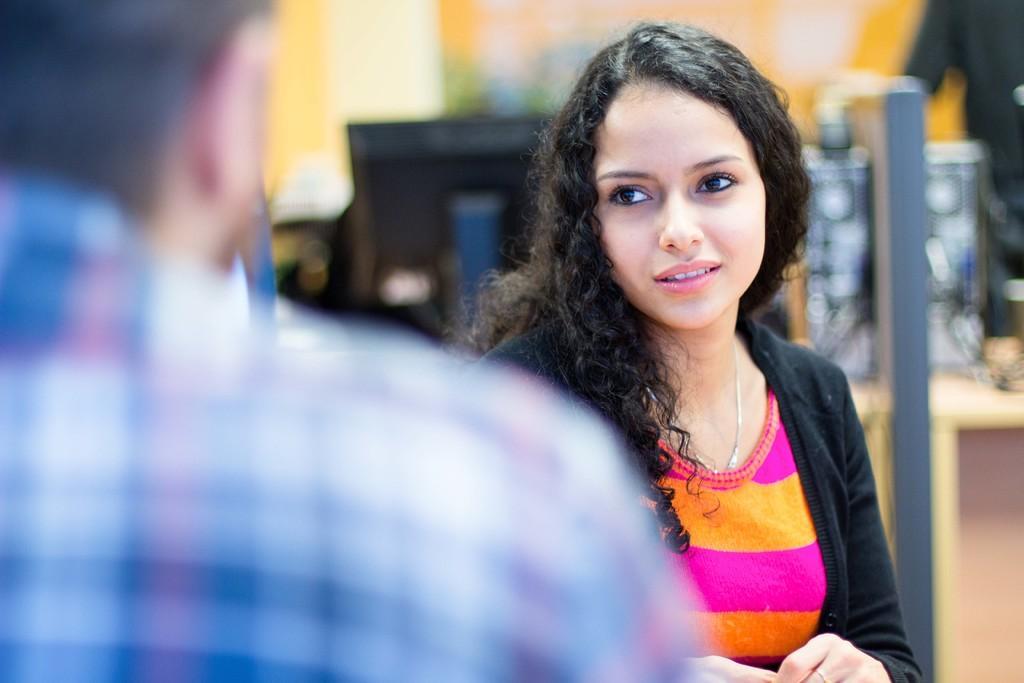Can you describe this image briefly? In the center of the image there is a lady. To the left side of the image there is a person. In the background of the image there is a monitor. 